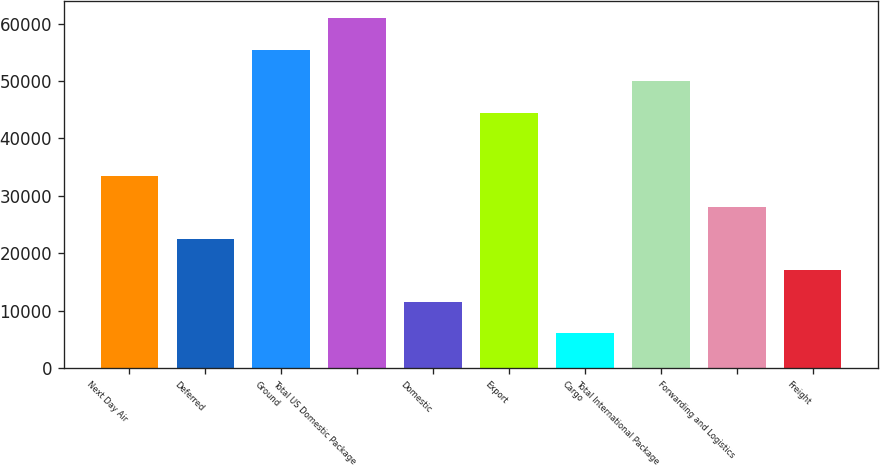<chart> <loc_0><loc_0><loc_500><loc_500><bar_chart><fcel>Next Day Air<fcel>Deferred<fcel>Ground<fcel>Total US Domestic Package<fcel>Domestic<fcel>Export<fcel>Cargo<fcel>Total International Package<fcel>Forwarding and Logistics<fcel>Freight<nl><fcel>33487.2<fcel>22511.8<fcel>55438<fcel>60925.7<fcel>11536.4<fcel>44462.6<fcel>6048.7<fcel>49950.3<fcel>27999.5<fcel>17024.1<nl></chart> 